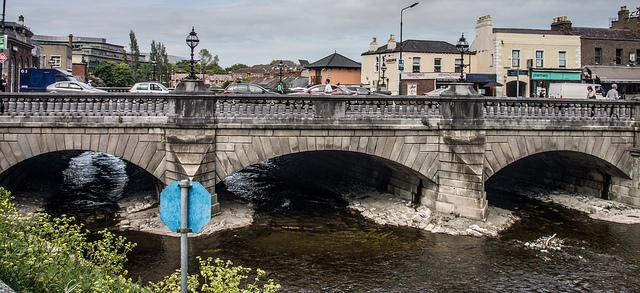What kind of river channel it is?

Choices:
A) sea
B) canal
C) pond
D) river canal 